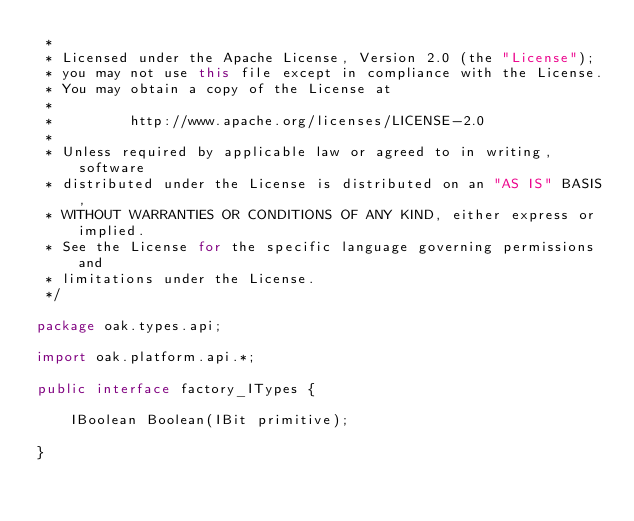Convert code to text. <code><loc_0><loc_0><loc_500><loc_500><_Java_> *
 * Licensed under the Apache License, Version 2.0 (the "License");
 * you may not use this file except in compliance with the License.
 * You may obtain a copy of the License at
 *
 *         http://www.apache.org/licenses/LICENSE-2.0
 *
 * Unless required by applicable law or agreed to in writing, software
 * distributed under the License is distributed on an "AS IS" BASIS,
 * WITHOUT WARRANTIES OR CONDITIONS OF ANY KIND, either express or implied.
 * See the License for the specific language governing permissions and
 * limitations under the License.
 */

package oak.types.api;

import oak.platform.api.*;

public interface factory_ITypes {

    IBoolean Boolean(IBit primitive);

}</code> 